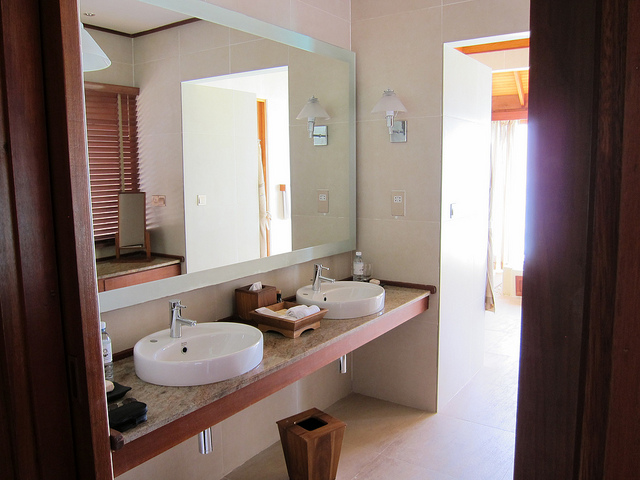What is the lighting like in the bathroom? The bathroom features subdued ambient lighting, primarily coming from wall-mounted light fixtures beside the mirror. Additionally, there’s a bright influx of natural light streaming in from a window, which highlights the clean lines of the design and creates a refreshing atmosphere. 